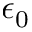<formula> <loc_0><loc_0><loc_500><loc_500>\epsilon _ { 0 }</formula> 